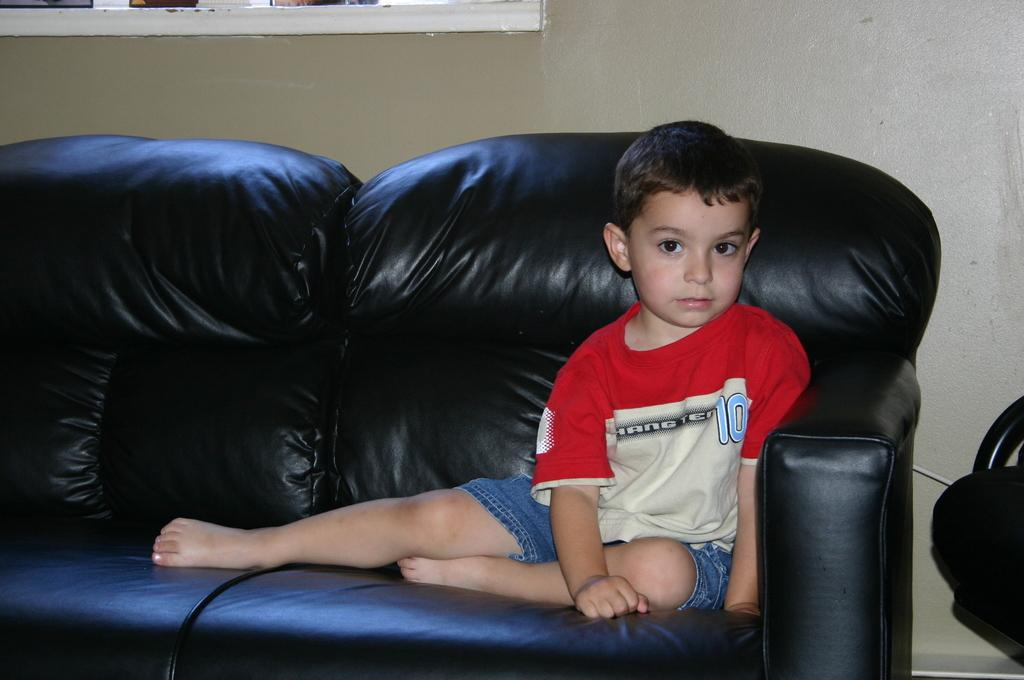Who is the main subject in the image? There is a boy in the image. What is the boy doing in the image? The boy is sitting on a sofa. What can be seen in the background of the image? There is a wall in the background of the image. What type of horn is the boy holding in the image? There is no horn present in the image; the boy is sitting on a sofa. 